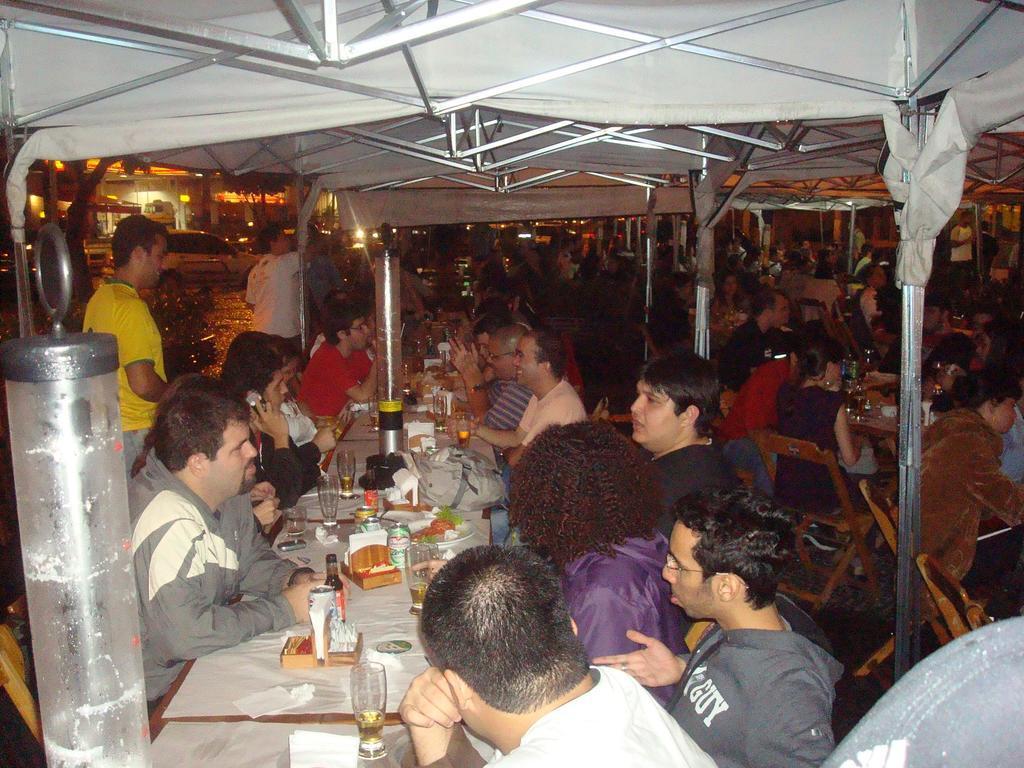Could you give a brief overview of what you see in this image? In this image we can see a group of people sitting on the chairs beside the tables containing some glasses, tins, tissue papers, bags, devices and some objects which are placed on them. We can also see some people standing and a roof with some metal poles. On the backside we can see some cars on the ground and a building. 